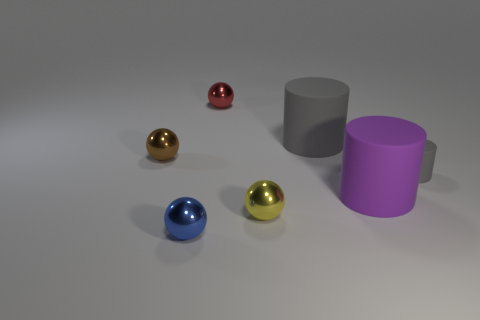Subtract all gray rubber cylinders. How many cylinders are left? 1 Add 1 tiny spheres. How many objects exist? 8 Subtract all brown balls. How many balls are left? 3 Subtract all spheres. How many objects are left? 3 Subtract 2 cylinders. How many cylinders are left? 1 Subtract all red blocks. How many brown cylinders are left? 0 Subtract all small yellow objects. Subtract all matte balls. How many objects are left? 6 Add 3 tiny matte things. How many tiny matte things are left? 4 Add 4 tiny brown shiny objects. How many tiny brown shiny objects exist? 5 Subtract 1 brown spheres. How many objects are left? 6 